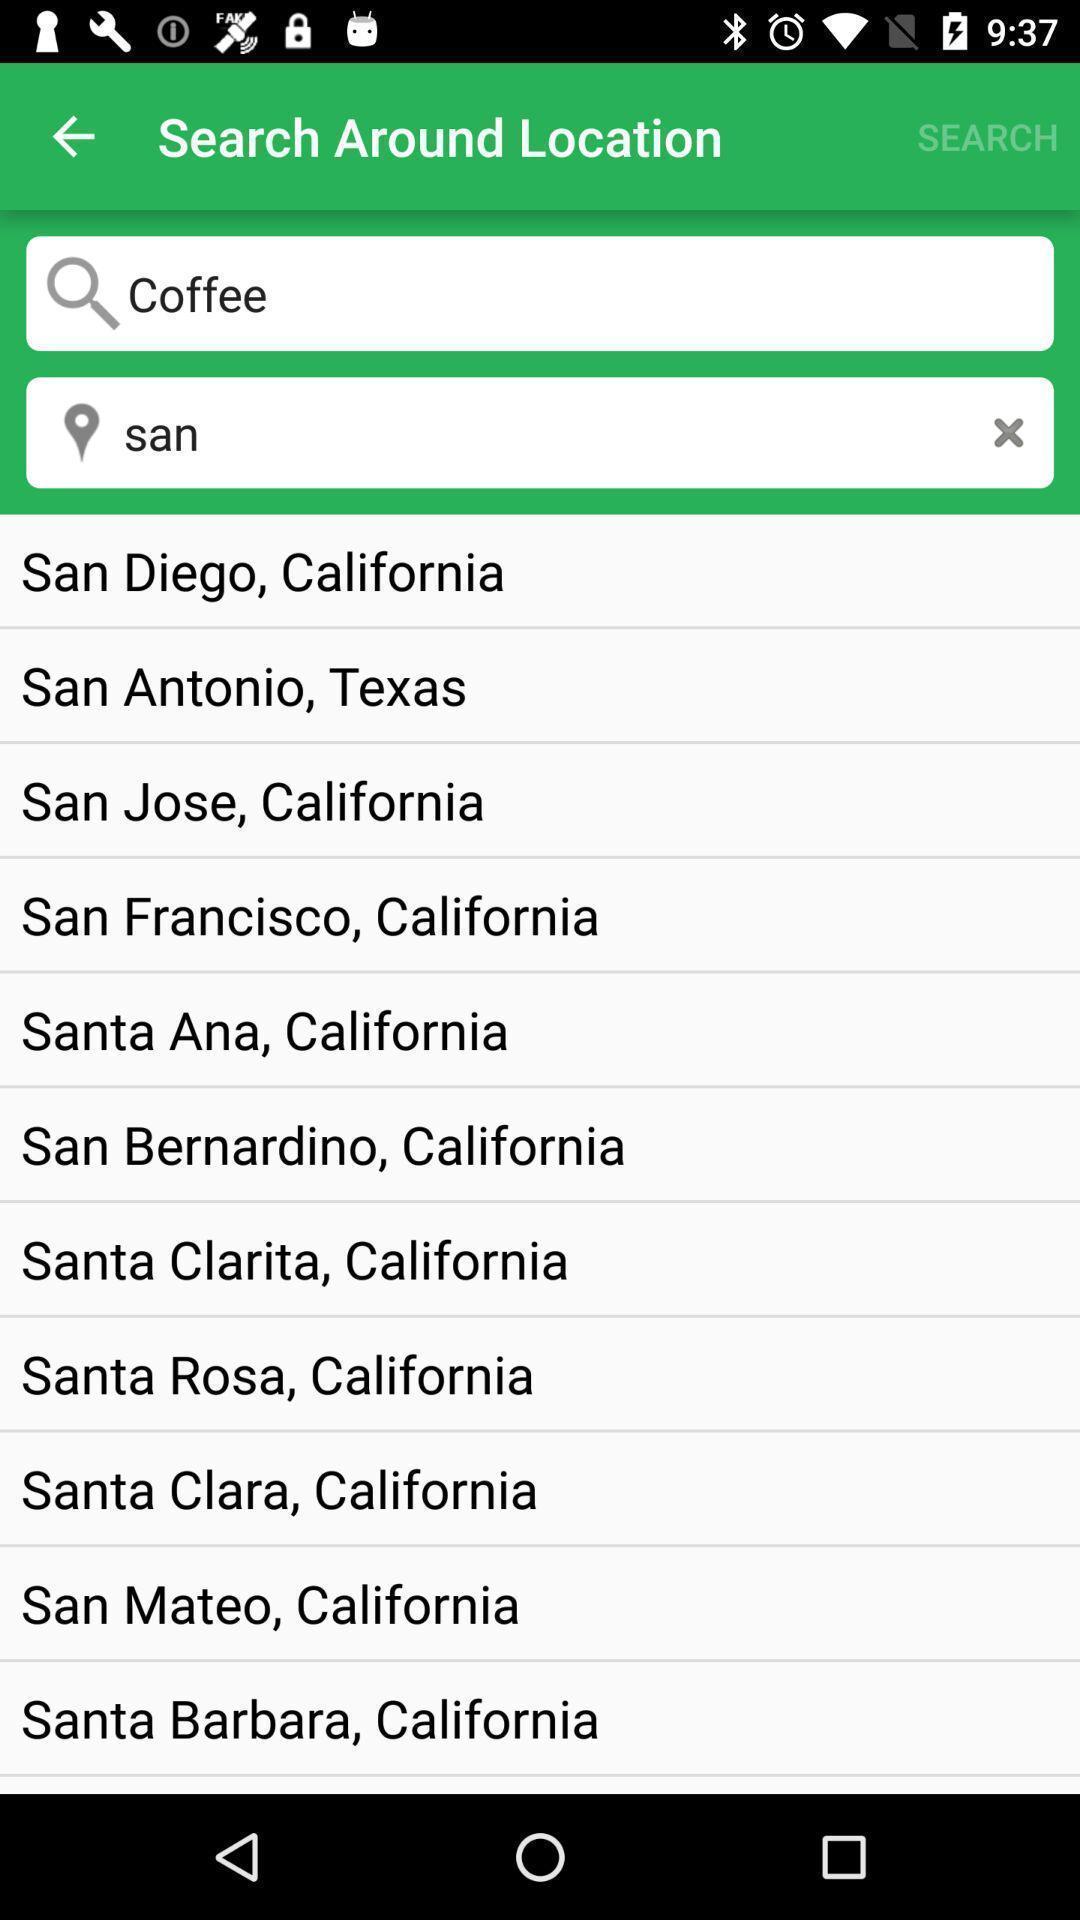Describe the visual elements of this screenshot. Search bar to find the address. 